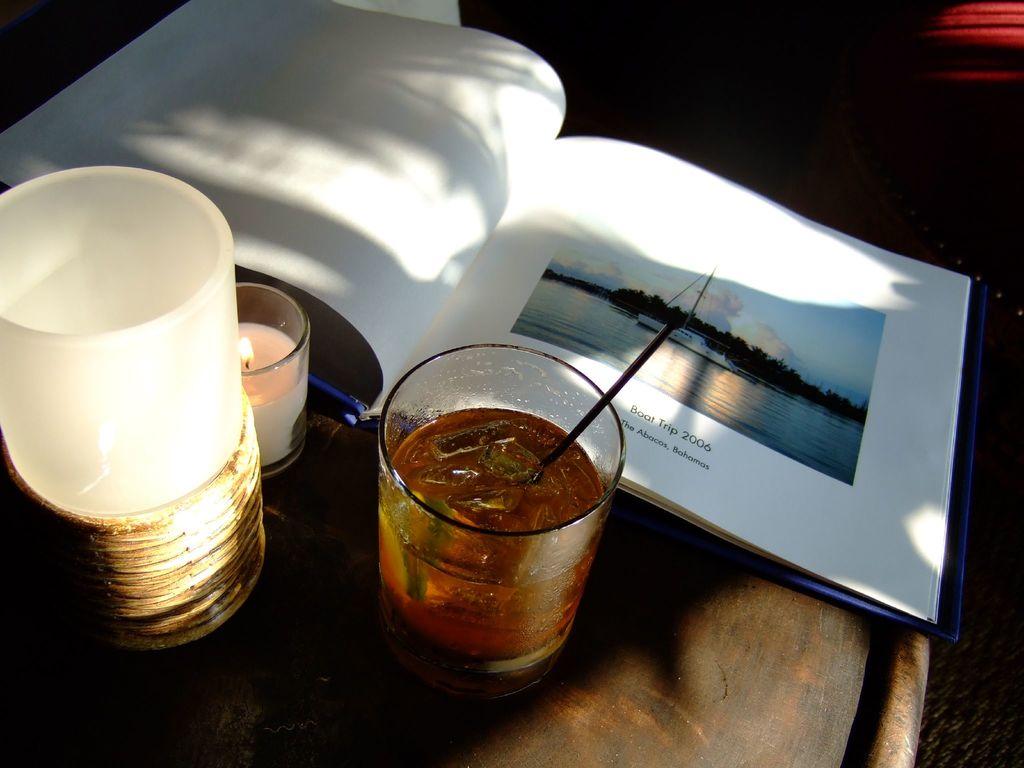What year was the boat trip?
Keep it short and to the point. 2006. 